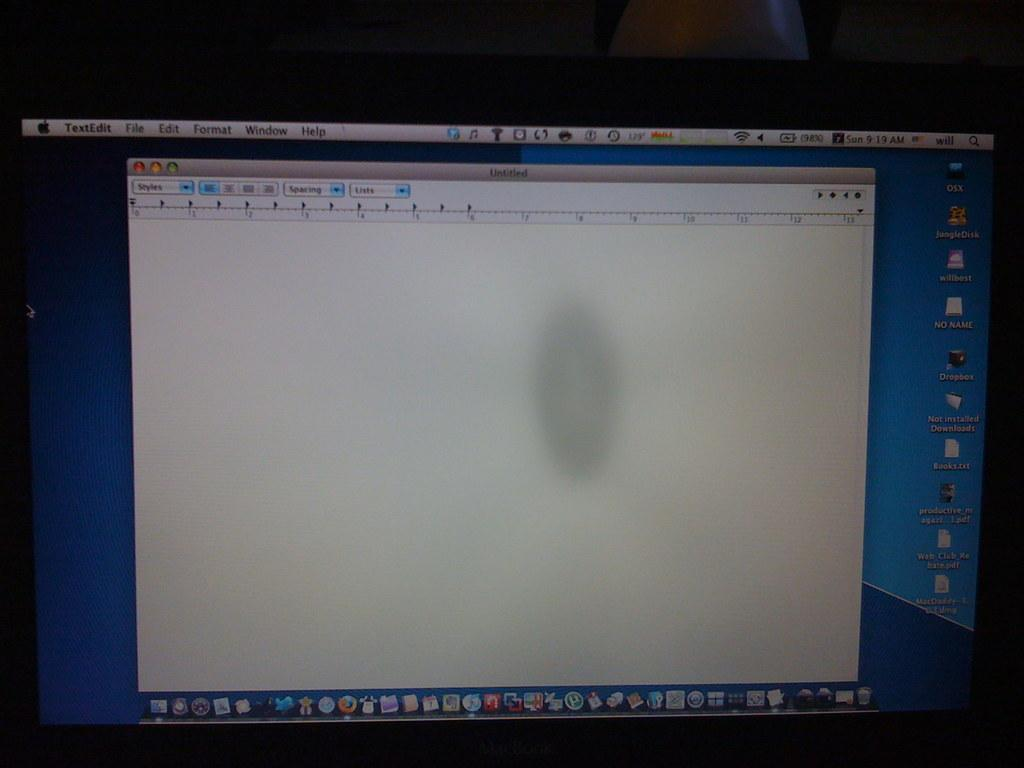What is the main feature of the image? There is a screen in the image. What can be seen on the screen? There are icons, words, and a menu bar on the screen. What type of root can be seen growing on the screen in the image? There is no root present on the screen in the image; it is a digital display with icons, words, and a menu bar. 